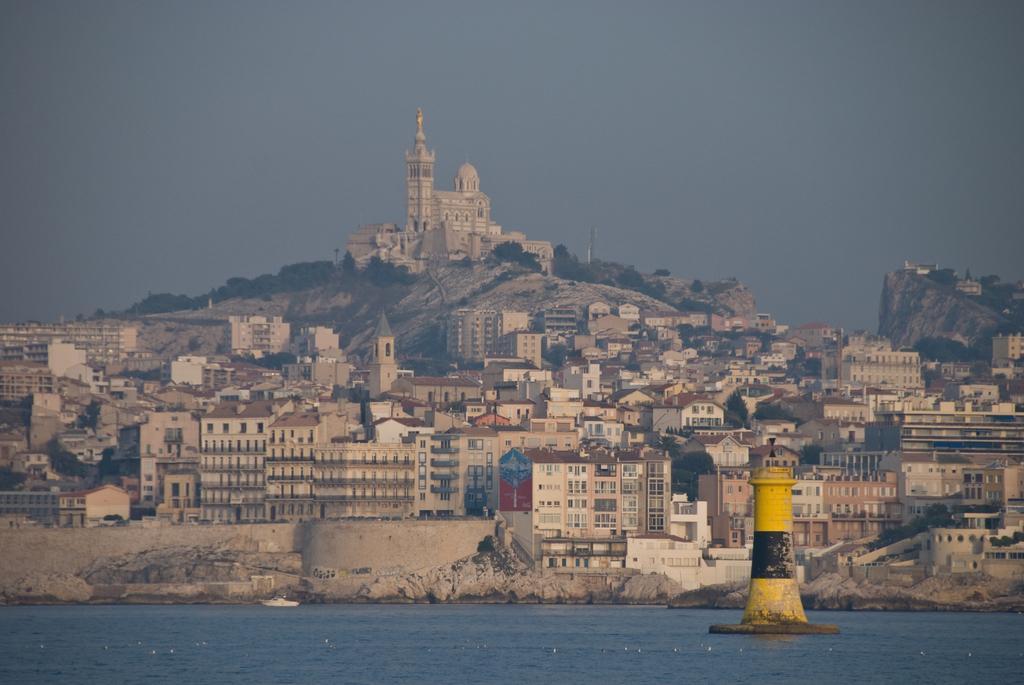Describe this image in one or two sentences. In the center of the image we can see buildings, mountains, trees, tower are present. At the top of the image sky is there. At the bottom of the image we can see water, boat, tower house are there. 